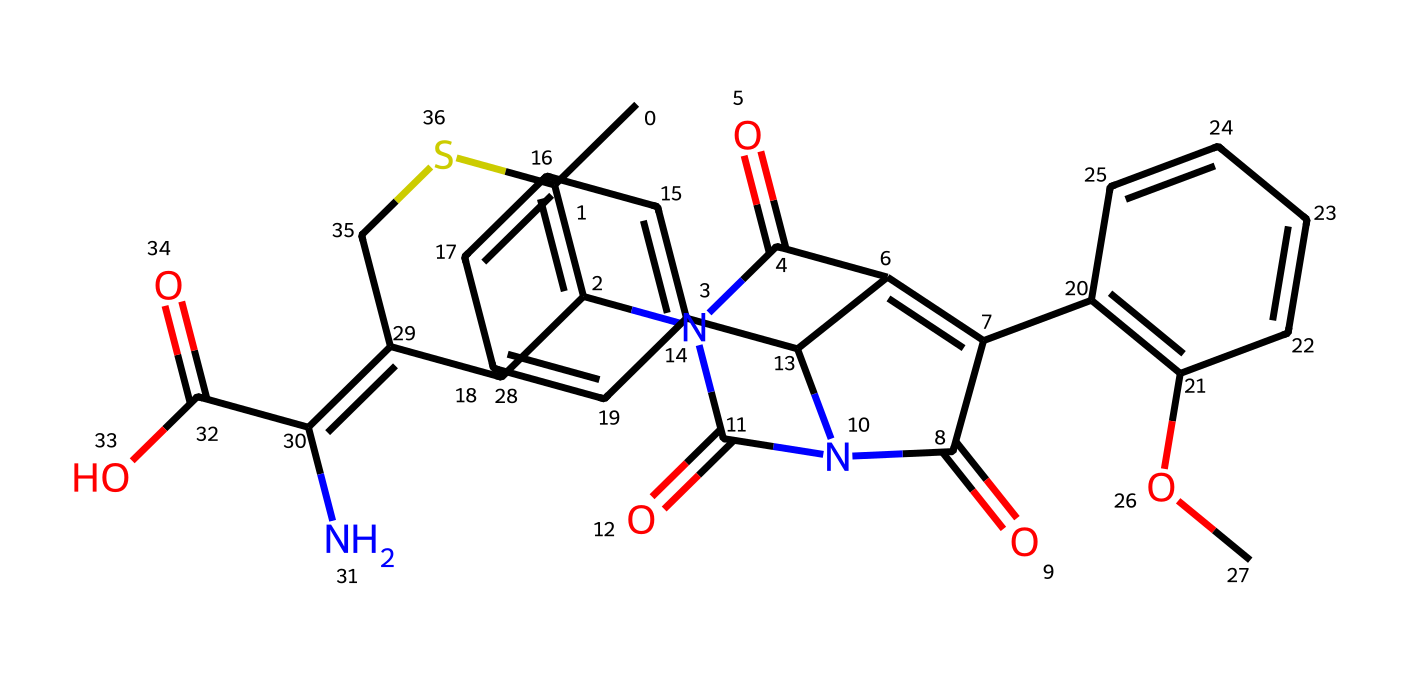What is the main class of this compound? This compound belongs to the class of cephalosporin antibiotics, which is characterized by its beta-lactam structure and diverse chemical modifications. Specifically, its structure includes a beta-lactam ring that is pivotal for its antimicrobial activity.
Answer: cephalosporin How many nitrogen atoms are present in the chemical structure? By examining the SMILES representation closely, there are four nitrogen atoms indicated by 'N' symbols throughout the structure. This is crucial for its antimicrobial properties and functionality.
Answer: four What type of functional group is primarily responsible for the antibiotic activity? The beta-lactam ring present in the SMILES structure is critical for the antibiotic activity, as it interferes with bacterial cell wall synthesis. The presence of this functional group is characteristic for cephalosporins and penicillins.
Answer: beta-lactam What is the molecular weight approximation of this compound? To estimate the molecular weight, one would typically count the different atoms and account for their standard atomic weights: carbon (C), hydrogen (H), nitrogen (N), and oxygen (O). The calculated molecular weight for this structure is approximately 500 g/mol.
Answer: approximately 500 Which part of the structure contains the characteristic bicyclic system? The bicyclic system can be identified in the compound by looking at the beta-lactam ring, which consists of a cyclic amide fused with another ring containing carbon atoms. This property is distinctive to cephalosporins and contributes to their function.
Answer: beta-lactam ring How many carbons are present in the structure? Counting the number of carbon atoms from the SMILES representation reveals there are 22 carbon atoms. This is important as it contributes to the overall structure and lipophilicity of the antibiotic compound.
Answer: twenty-two 